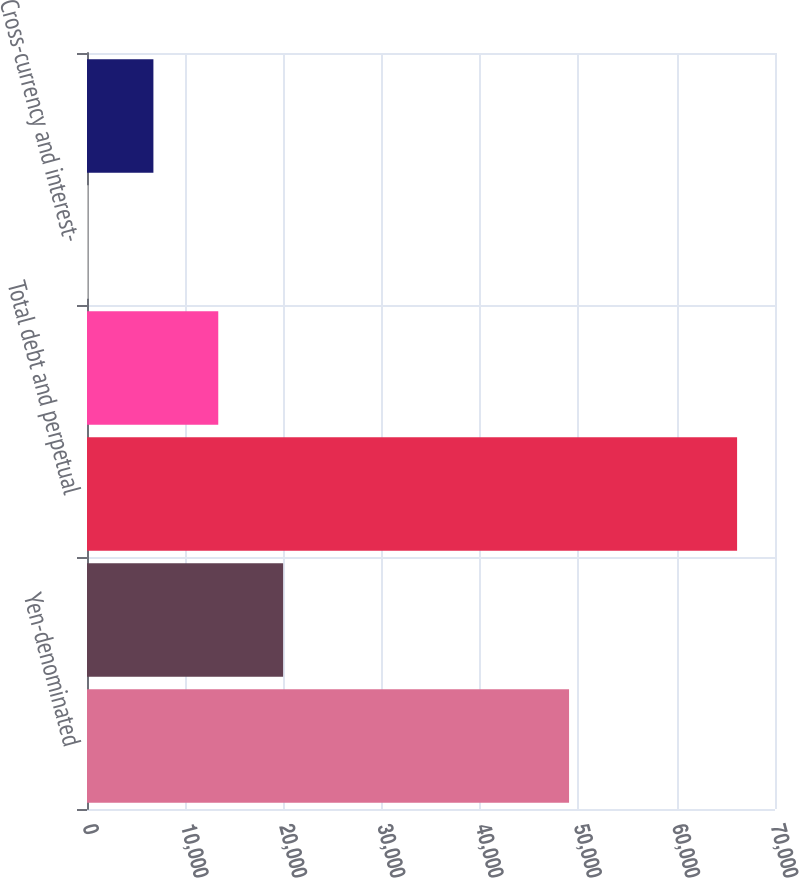<chart> <loc_0><loc_0><loc_500><loc_500><bar_chart><fcel>Yen-denominated<fcel>Dollar-denominated<fcel>Total debt and perpetual<fcel>Notes payable<fcel>Cross-currency and interest-<fcel>Japanese policyholder<nl><fcel>49047<fcel>19953.5<fcel>66143<fcel>13355<fcel>158<fcel>6756.5<nl></chart> 